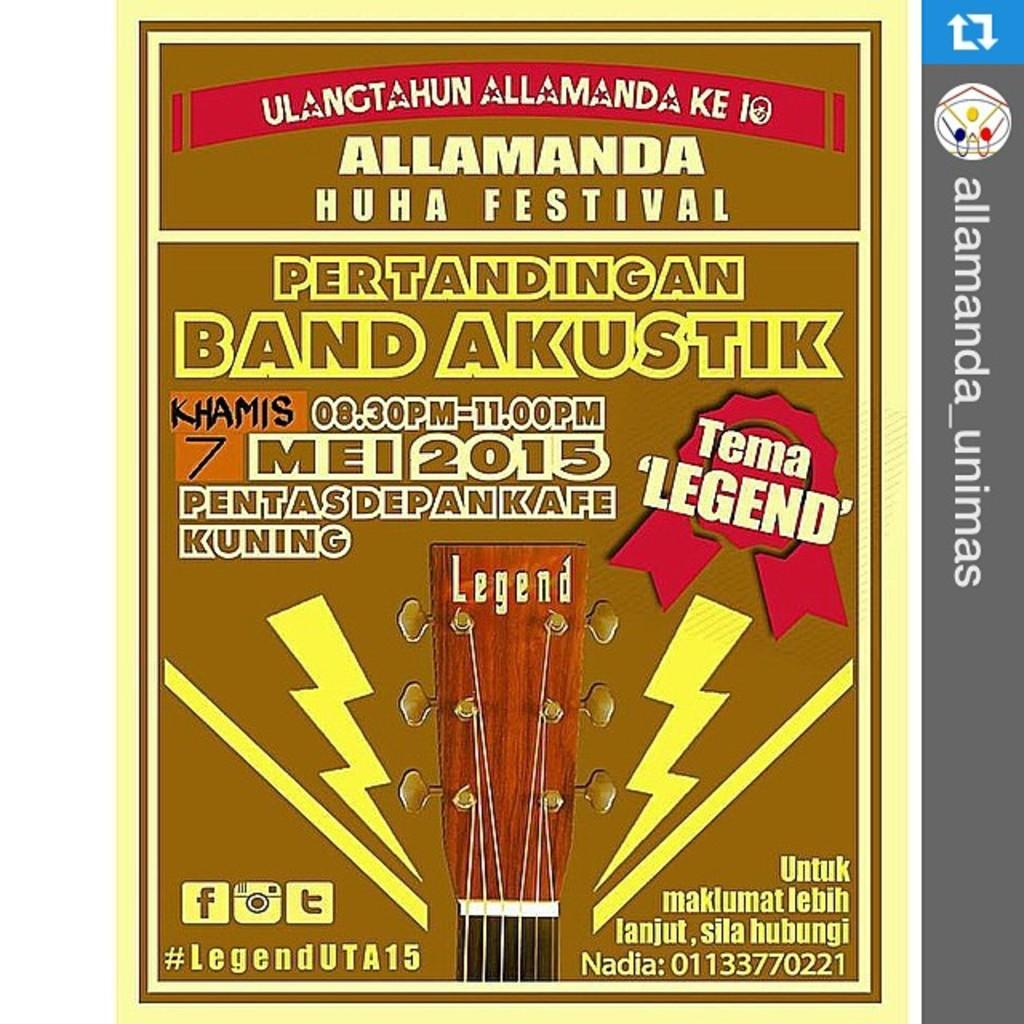<image>
Relay a brief, clear account of the picture shown. An ad for the Allamanda Huha Festival includes an image of a guitar neck. 